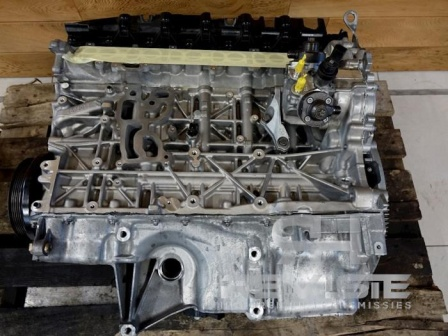Considering the parts visible, which systems of the car are directly influenced by the state of this engine block? The engine block directly influences several critical systems of the car. These include the fuel and air intake system, as the engine block houses the cylinders where fuel is combusted. The cooling system is also impacted because the engine block must dissipate heat efficiently to prevent overheating. Additionally, the lubrication system is affected since the engine oil circulates through passages in the engine block to reduce friction and wear. These systems must operate harmoniously for the vehicle to function reliably. How important is the cooling system for the engine block, and why? The cooling system is crucial for the engine block because it regulates the engine's temperature. During operation, the engine generates a significant amount of heat due to fuel combustion and friction between moving parts. If this heat is not adequately dissipated, it can lead to overheating, causing severe damage to the engine, such as warped components or even catastrophic failure. The cooling system circulates coolant through passages in the engine block, absorbing heat and dissipating it through the radiator, ensuring the engine operates within a safe temperature range. 